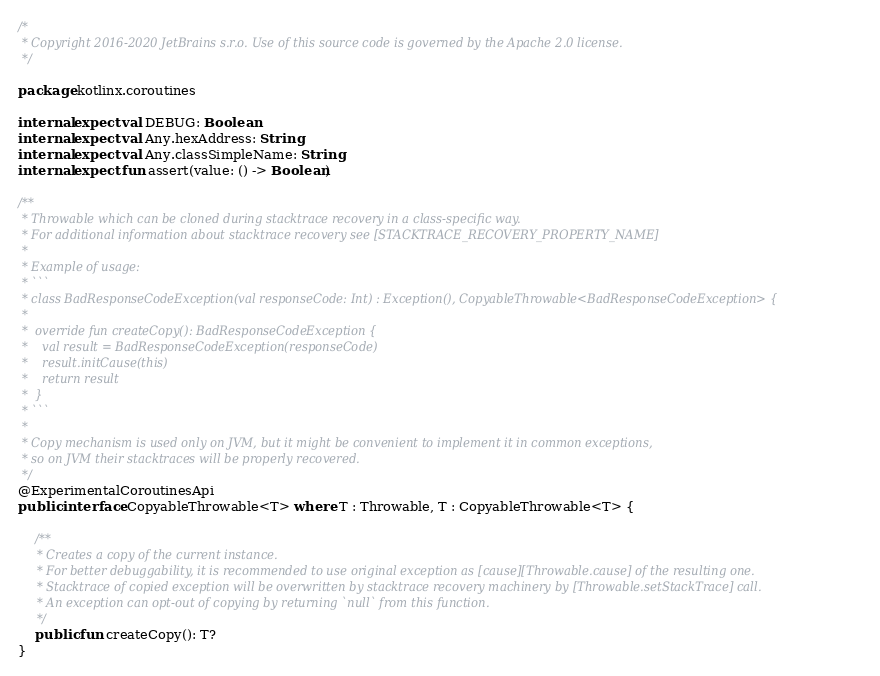<code> <loc_0><loc_0><loc_500><loc_500><_Kotlin_>/*
 * Copyright 2016-2020 JetBrains s.r.o. Use of this source code is governed by the Apache 2.0 license.
 */

package kotlinx.coroutines

internal expect val DEBUG: Boolean
internal expect val Any.hexAddress: String
internal expect val Any.classSimpleName: String
internal expect fun assert(value: () -> Boolean)

/**
 * Throwable which can be cloned during stacktrace recovery in a class-specific way.
 * For additional information about stacktrace recovery see [STACKTRACE_RECOVERY_PROPERTY_NAME]
 *
 * Example of usage:
 * ```
 * class BadResponseCodeException(val responseCode: Int) : Exception(), CopyableThrowable<BadResponseCodeException> {
 *
 *  override fun createCopy(): BadResponseCodeException {
 *    val result = BadResponseCodeException(responseCode)
 *    result.initCause(this)
 *    return result
 *  }
 * ```
 *
 * Copy mechanism is used only on JVM, but it might be convenient to implement it in common exceptions,
 * so on JVM their stacktraces will be properly recovered.
 */
@ExperimentalCoroutinesApi
public interface CopyableThrowable<T> where T : Throwable, T : CopyableThrowable<T> {

    /**
     * Creates a copy of the current instance.
     * For better debuggability, it is recommended to use original exception as [cause][Throwable.cause] of the resulting one.
     * Stacktrace of copied exception will be overwritten by stacktrace recovery machinery by [Throwable.setStackTrace] call.
     * An exception can opt-out of copying by returning `null` from this function.
     */
    public fun createCopy(): T?
}
</code> 